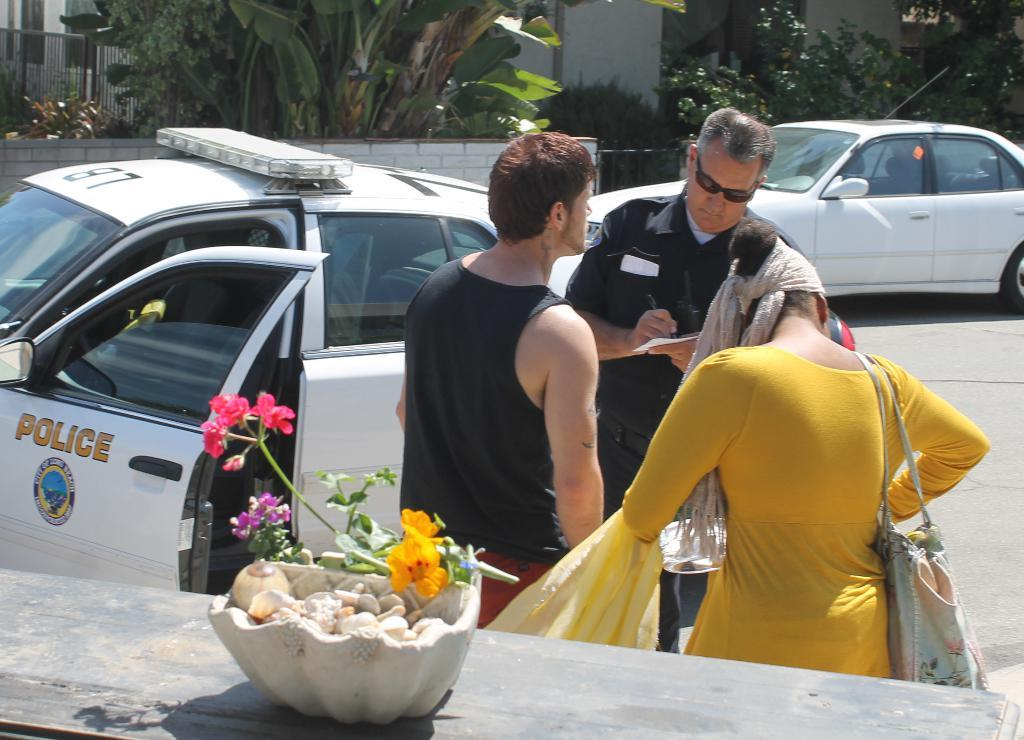Provide a one-sentence caption for the provided image. A City of Long Beach Police officer writes a statement while talking to a man and a women outside his car. 